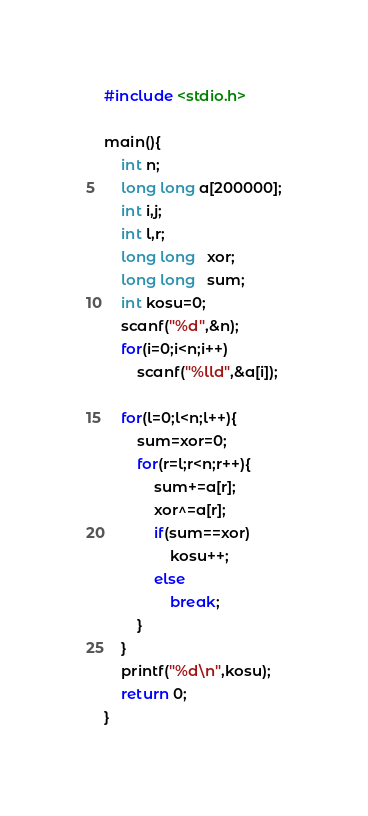<code> <loc_0><loc_0><loc_500><loc_500><_C_>#include <stdio.h>

main(){
    int n;
    long long a[200000];
    int i,j;
    int l,r;
    long long   xor;
    long long   sum;
    int kosu=0;
    scanf("%d",&n);
    for(i=0;i<n;i++)
        scanf("%lld",&a[i]);

    for(l=0;l<n;l++){
        sum=xor=0;
        for(r=l;r<n;r++){
            sum+=a[r];
            xor^=a[r];
            if(sum==xor)
                kosu++;
            else
                break;
        }
    }
    printf("%d\n",kosu);
    return 0;
}</code> 